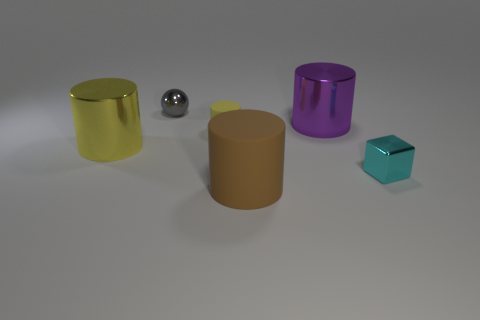Add 4 yellow balls. How many objects exist? 10 Subtract all blocks. How many objects are left? 5 Add 2 big yellow objects. How many big yellow objects exist? 3 Subtract 0 green cylinders. How many objects are left? 6 Subtract all gray cylinders. Subtract all tiny gray metal balls. How many objects are left? 5 Add 1 big brown rubber cylinders. How many big brown rubber cylinders are left? 2 